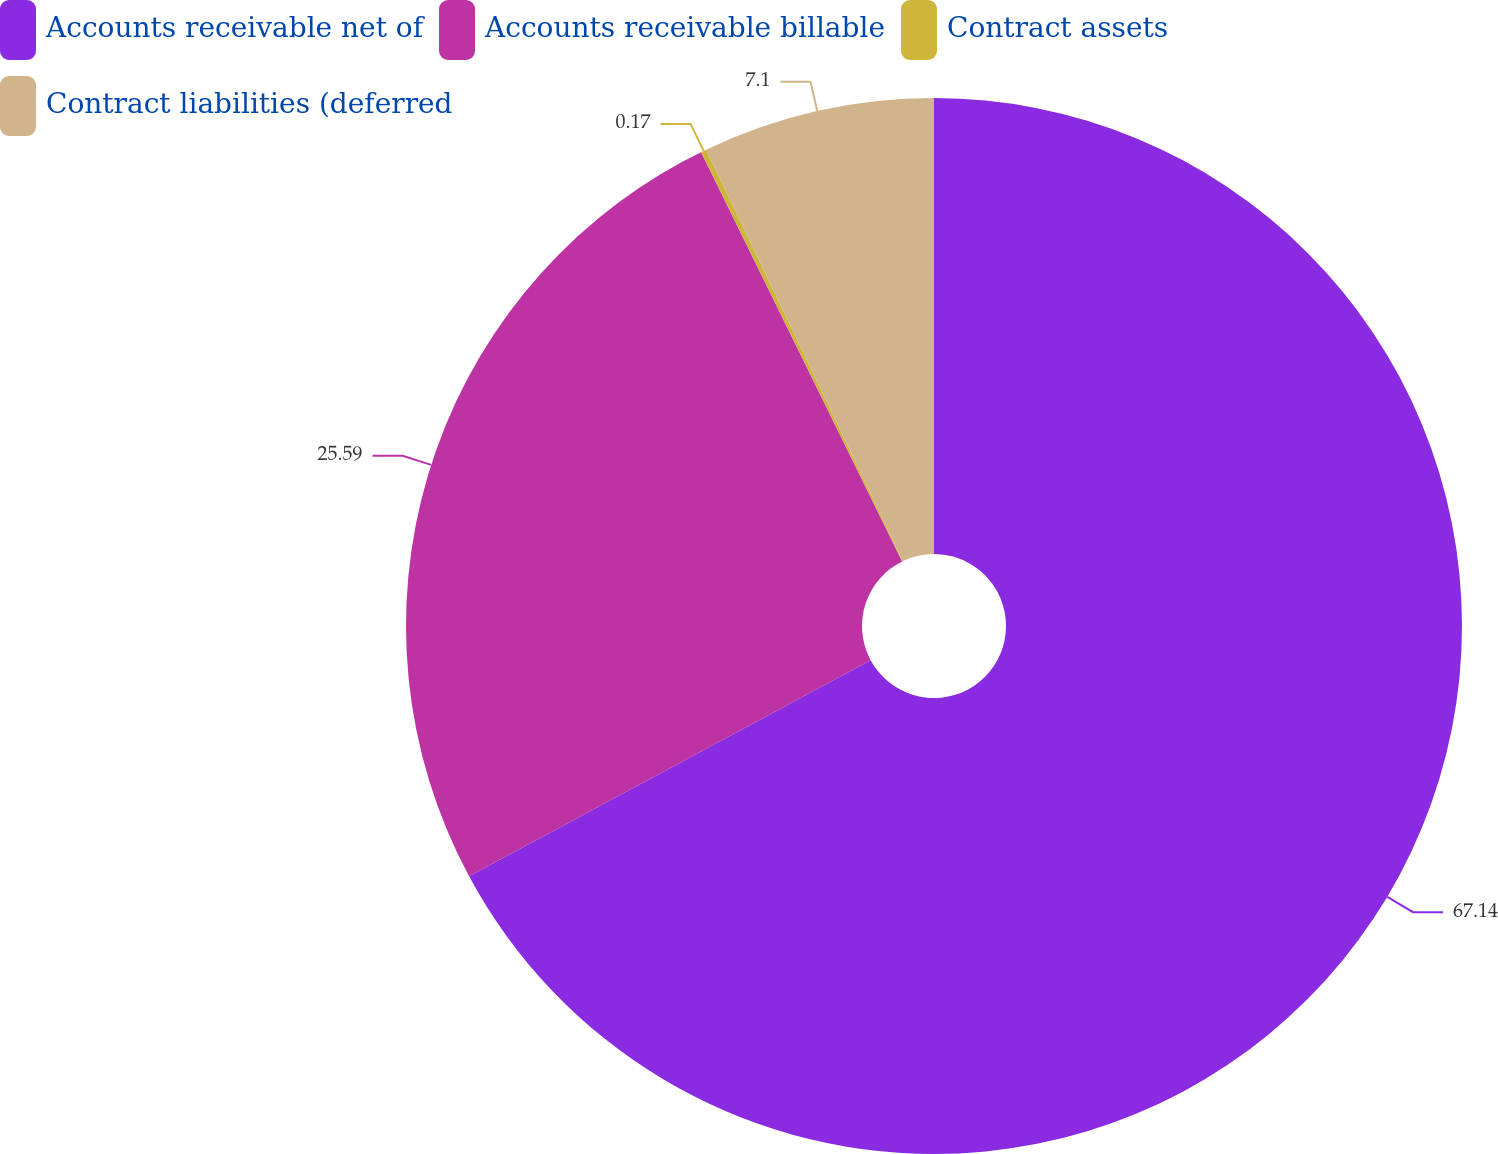<chart> <loc_0><loc_0><loc_500><loc_500><pie_chart><fcel>Accounts receivable net of<fcel>Accounts receivable billable<fcel>Contract assets<fcel>Contract liabilities (deferred<nl><fcel>67.14%<fcel>25.59%<fcel>0.17%<fcel>7.1%<nl></chart> 